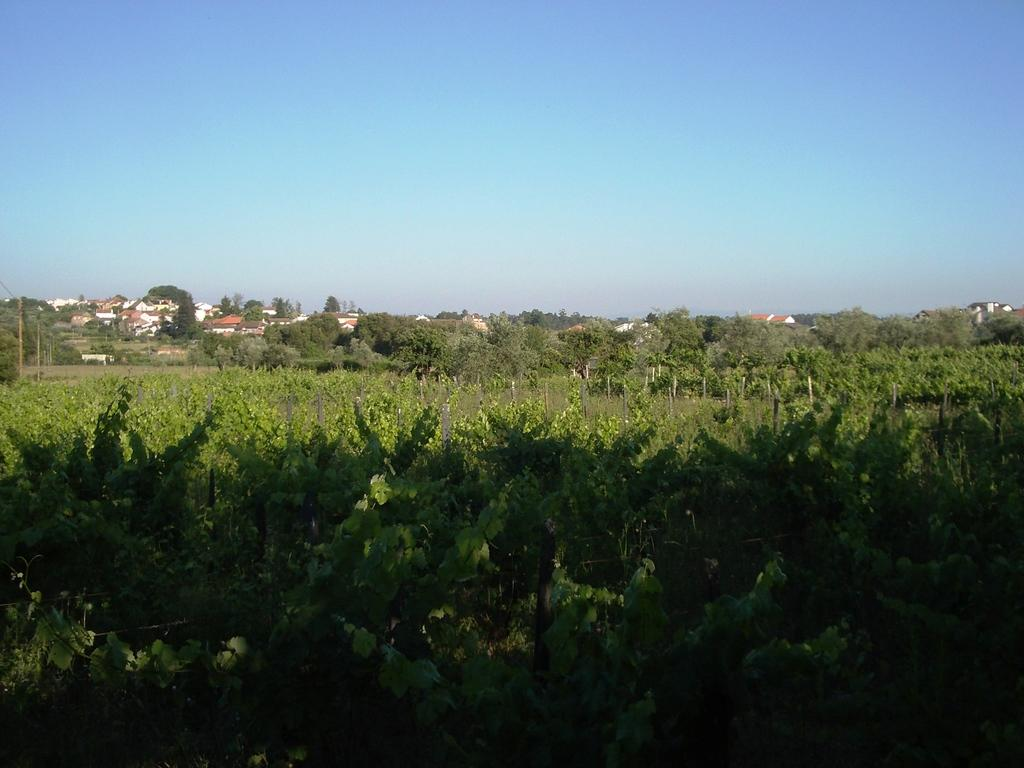What type of vegetation can be seen in the image? There are plants and trees in the image. What structures are present in the image? There are poles and houses in the image. What is visible in the background of the image? The sky is visible in the background of the image. What type of jam is being spread on the field in the image? There is no field or jam present in the image. How do the plants in the image behave when interacting with the poles? The plants in the image do not interact with the poles, and therefore their behavior cannot be observed. 